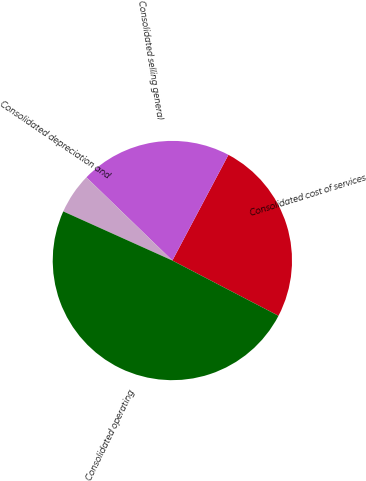Convert chart. <chart><loc_0><loc_0><loc_500><loc_500><pie_chart><fcel>Consolidated cost of services<fcel>Consolidated selling general<fcel>Consolidated depreciation and<fcel>Consolidated operating<nl><fcel>24.88%<fcel>20.52%<fcel>5.51%<fcel>49.09%<nl></chart> 